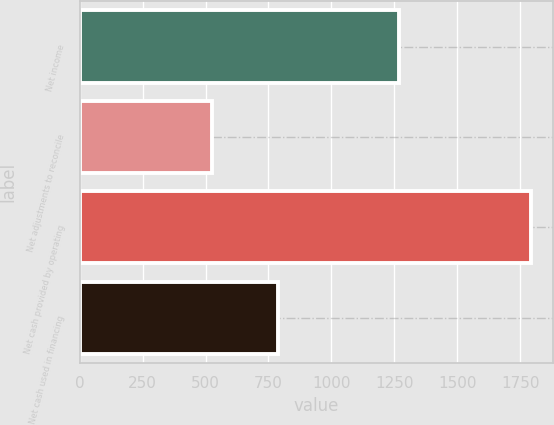Convert chart. <chart><loc_0><loc_0><loc_500><loc_500><bar_chart><fcel>Net income<fcel>Net adjustments to reconcile<fcel>Net cash provided by operating<fcel>Net cash used in financing<nl><fcel>1267<fcel>525<fcel>1792<fcel>788<nl></chart> 